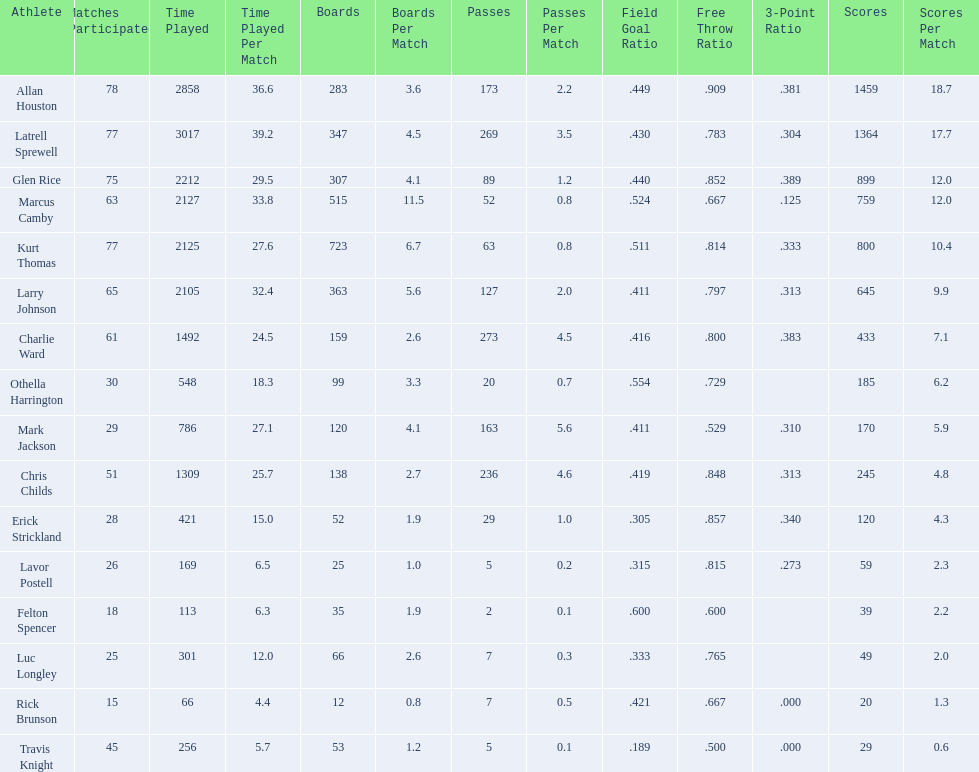How many games did larry johnson play? 65. 